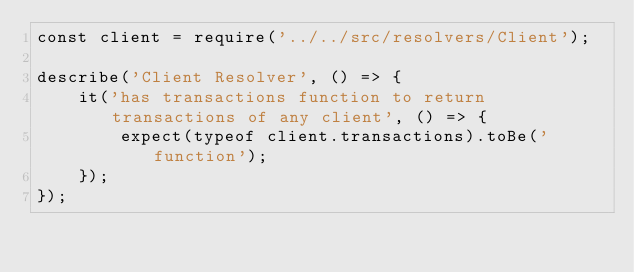<code> <loc_0><loc_0><loc_500><loc_500><_JavaScript_>const client = require('../../src/resolvers/Client');

describe('Client Resolver', () => {
    it('has transactions function to return transactions of any client', () => {
        expect(typeof client.transactions).toBe('function');
    });
});</code> 